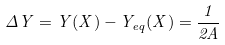Convert formula to latex. <formula><loc_0><loc_0><loc_500><loc_500>\Delta Y = Y ( X ) - Y _ { e q } ( X ) = \frac { 1 } { 2 A }</formula> 